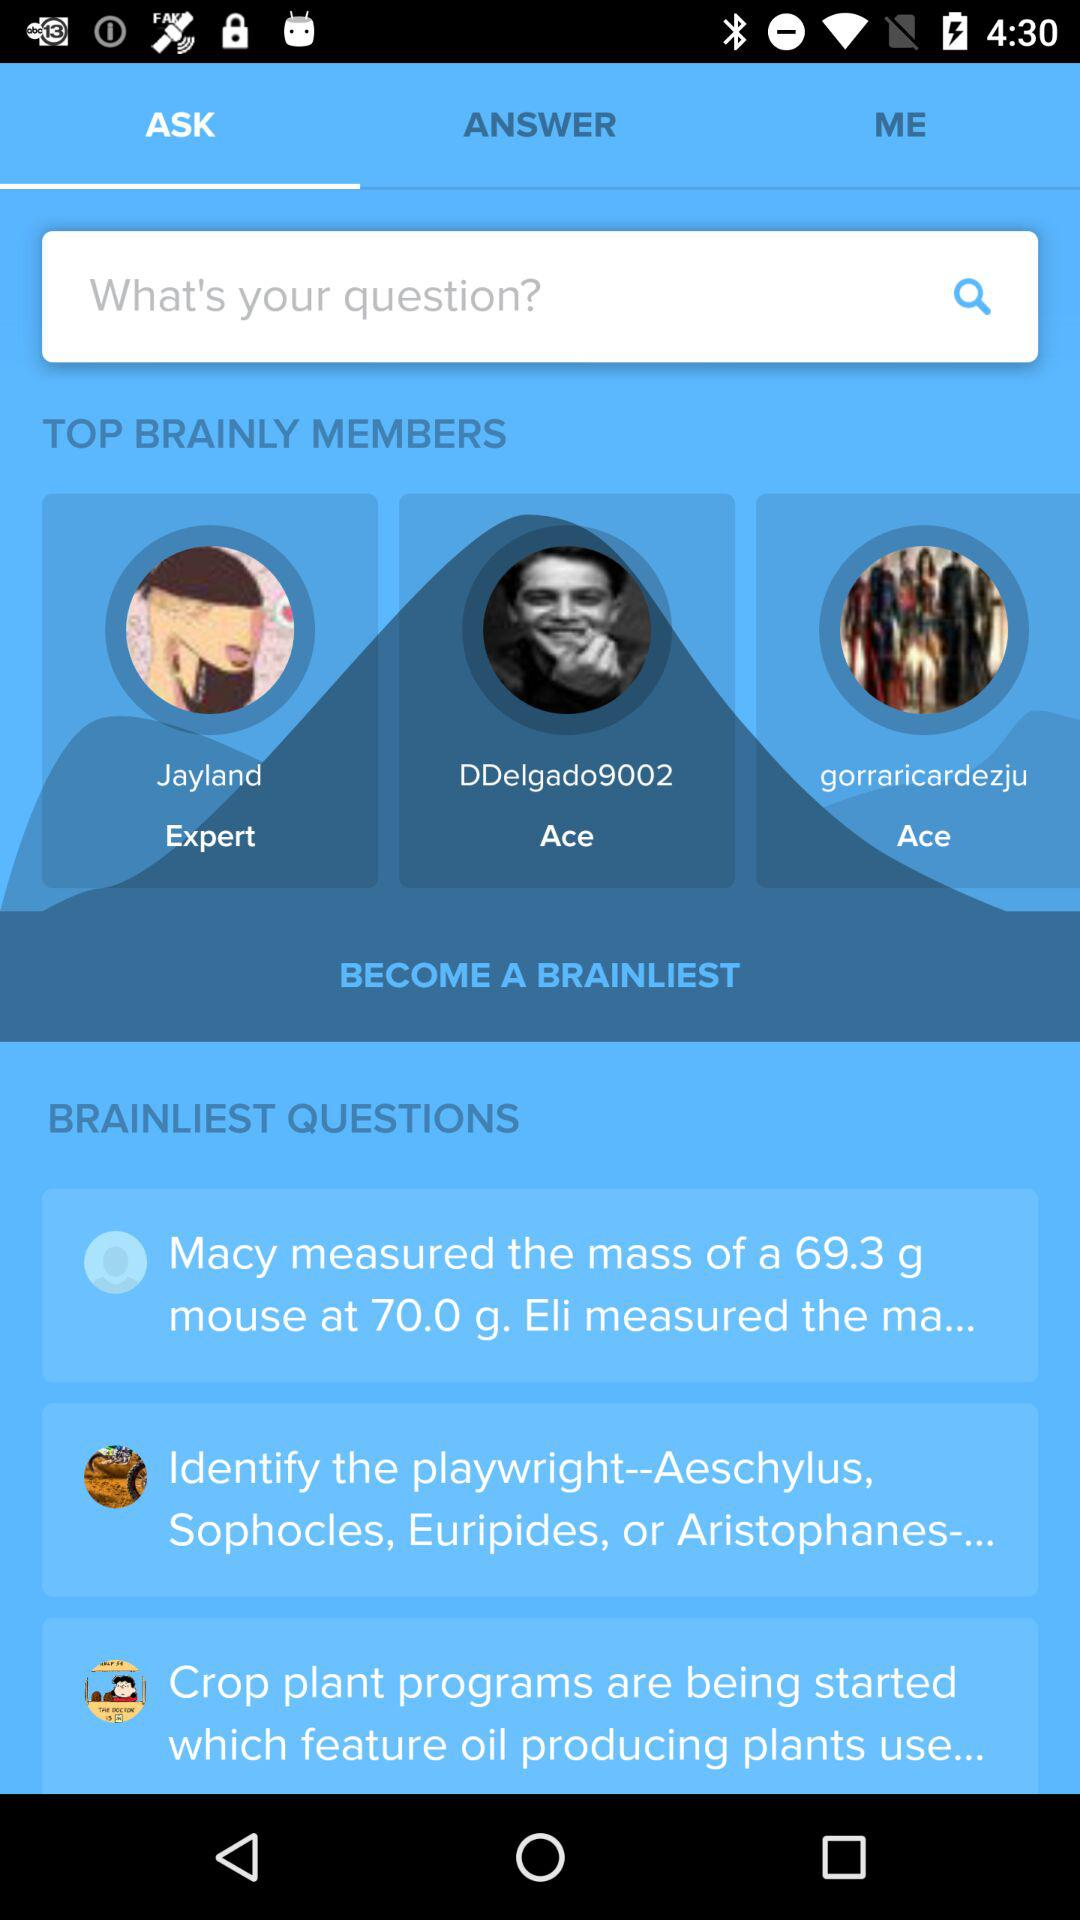Which tab am I using? You are using the tab "ASK". 